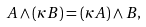Convert formula to latex. <formula><loc_0><loc_0><loc_500><loc_500>A \wedge \left ( \kappa B \right ) = \left ( \kappa A \right ) \wedge B ,</formula> 